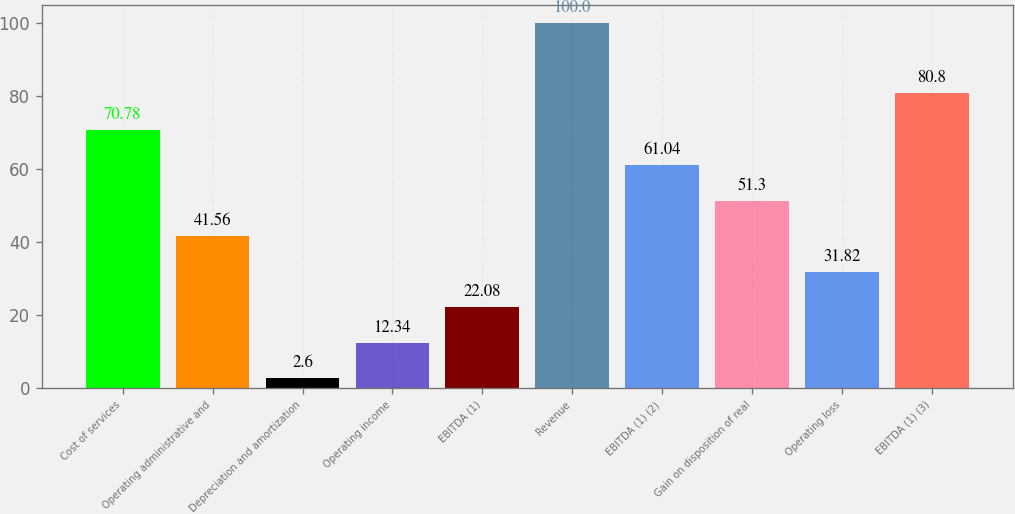<chart> <loc_0><loc_0><loc_500><loc_500><bar_chart><fcel>Cost of services<fcel>Operating administrative and<fcel>Depreciation and amortization<fcel>Operating income<fcel>EBITDA (1)<fcel>Revenue<fcel>EBITDA (1) (2)<fcel>Gain on disposition of real<fcel>Operating loss<fcel>EBITDA (1) (3)<nl><fcel>70.78<fcel>41.56<fcel>2.6<fcel>12.34<fcel>22.08<fcel>100<fcel>61.04<fcel>51.3<fcel>31.82<fcel>80.8<nl></chart> 